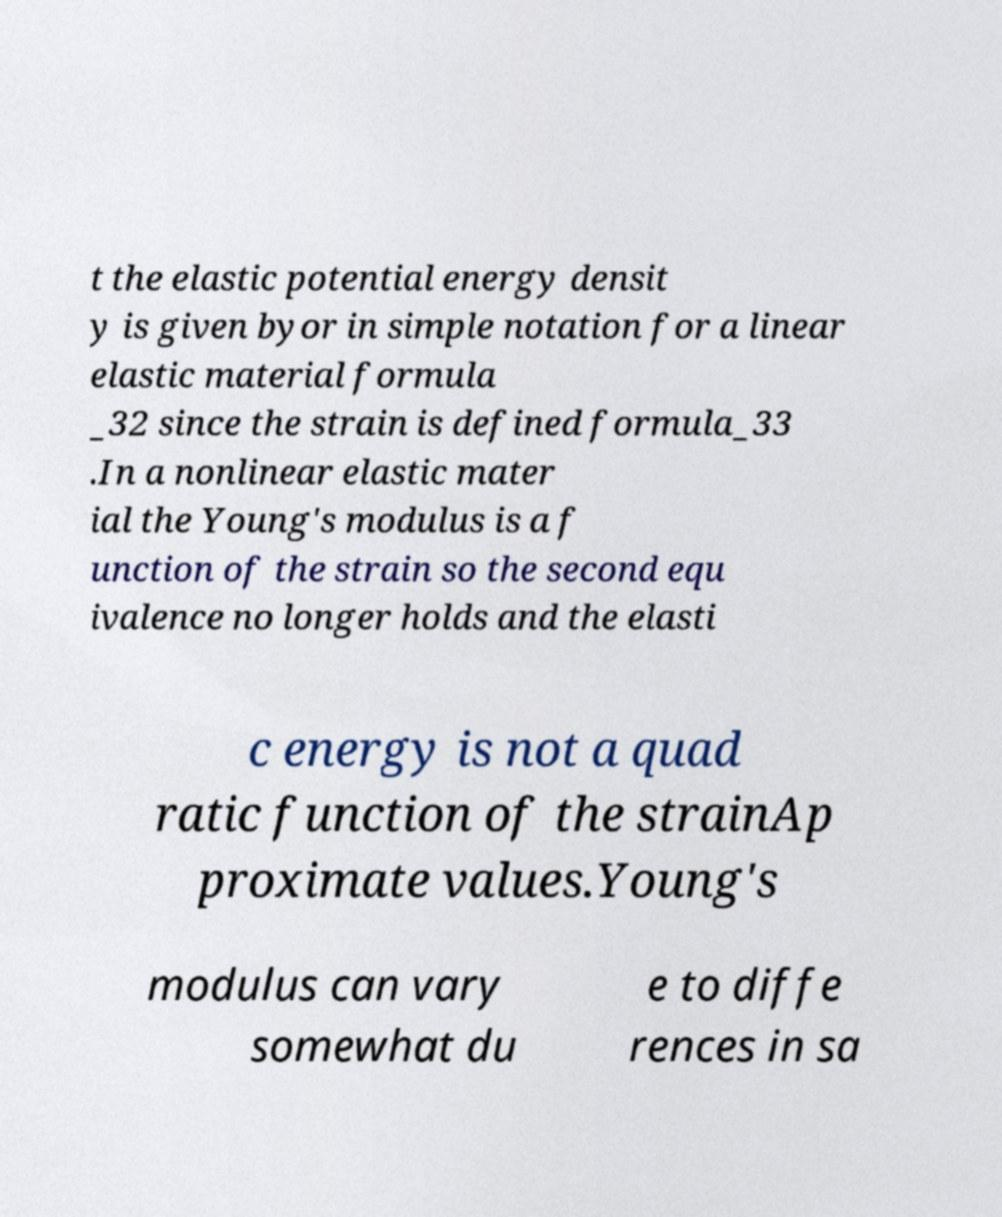Could you extract and type out the text from this image? t the elastic potential energy densit y is given byor in simple notation for a linear elastic material formula _32 since the strain is defined formula_33 .In a nonlinear elastic mater ial the Young's modulus is a f unction of the strain so the second equ ivalence no longer holds and the elasti c energy is not a quad ratic function of the strainAp proximate values.Young's modulus can vary somewhat du e to diffe rences in sa 